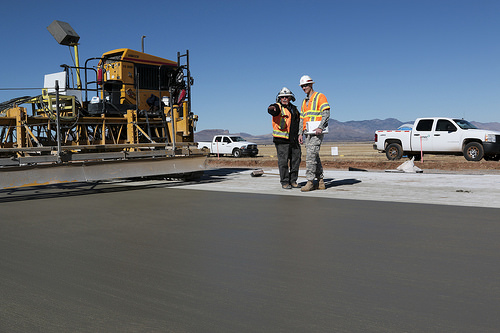<image>
Is there a man behind the car? No. The man is not behind the car. From this viewpoint, the man appears to be positioned elsewhere in the scene. 